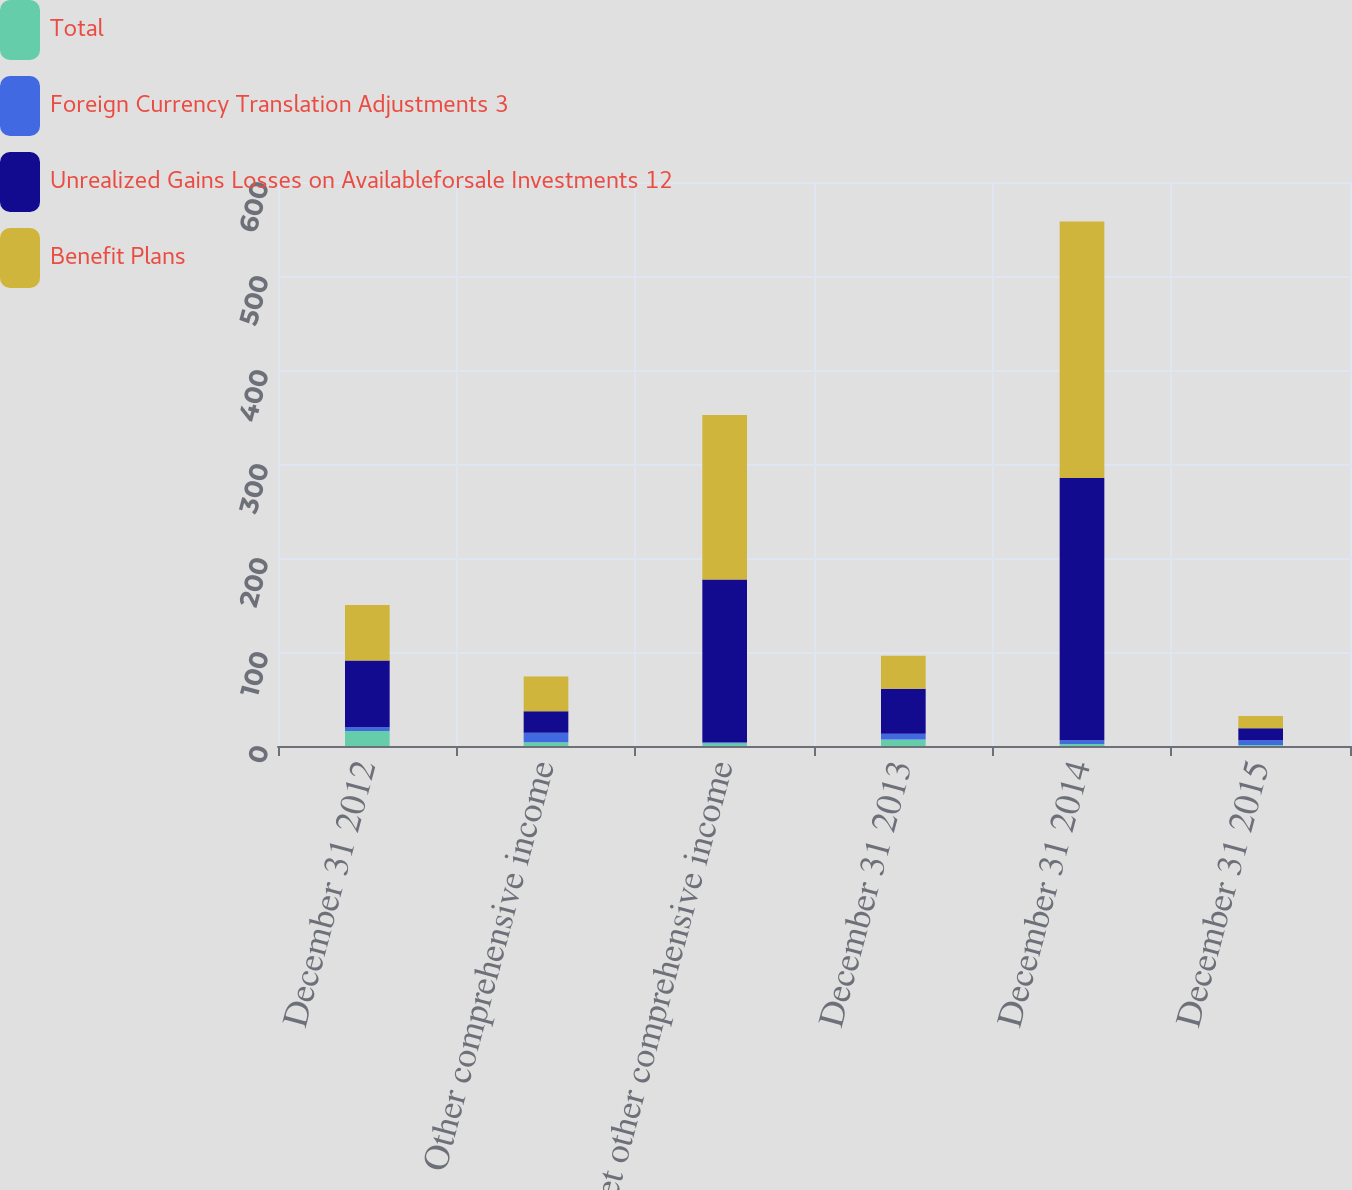Convert chart to OTSL. <chart><loc_0><loc_0><loc_500><loc_500><stacked_bar_chart><ecel><fcel>December 31 2012<fcel>Other comprehensive income<fcel>Net other comprehensive income<fcel>December 31 2013<fcel>December 31 2014<fcel>December 31 2015<nl><fcel>Total<fcel>16<fcel>4<fcel>3<fcel>7<fcel>2<fcel>1<nl><fcel>Foreign Currency Translation Adjustments 3<fcel>4<fcel>10<fcel>1<fcel>6<fcel>4<fcel>5<nl><fcel>Unrealized Gains Losses on Availableforsale Investments 12<fcel>71<fcel>23<fcel>173<fcel>48<fcel>279<fcel>13<nl><fcel>Benefit Plans<fcel>59<fcel>37<fcel>175<fcel>35<fcel>273<fcel>13<nl></chart> 